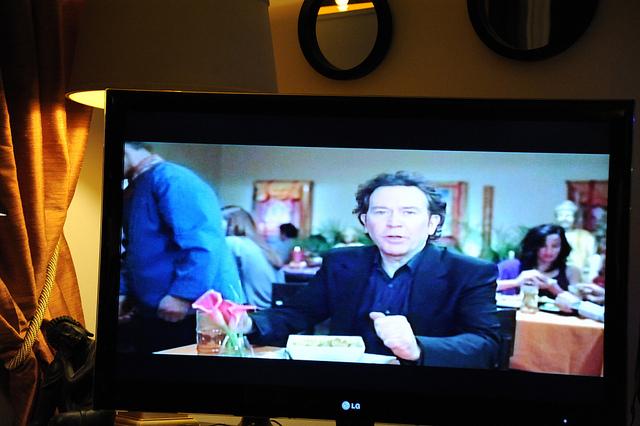Is this a a TV or Computer Monitor?
Keep it brief. Tv. Is this movie about a restaurant?
Short answer required. Yes. Who is on the television?
Quick response, please. Man. What is playing on the computer?
Keep it brief. Movie. What is the man talking about?
Quick response, please. Food. 